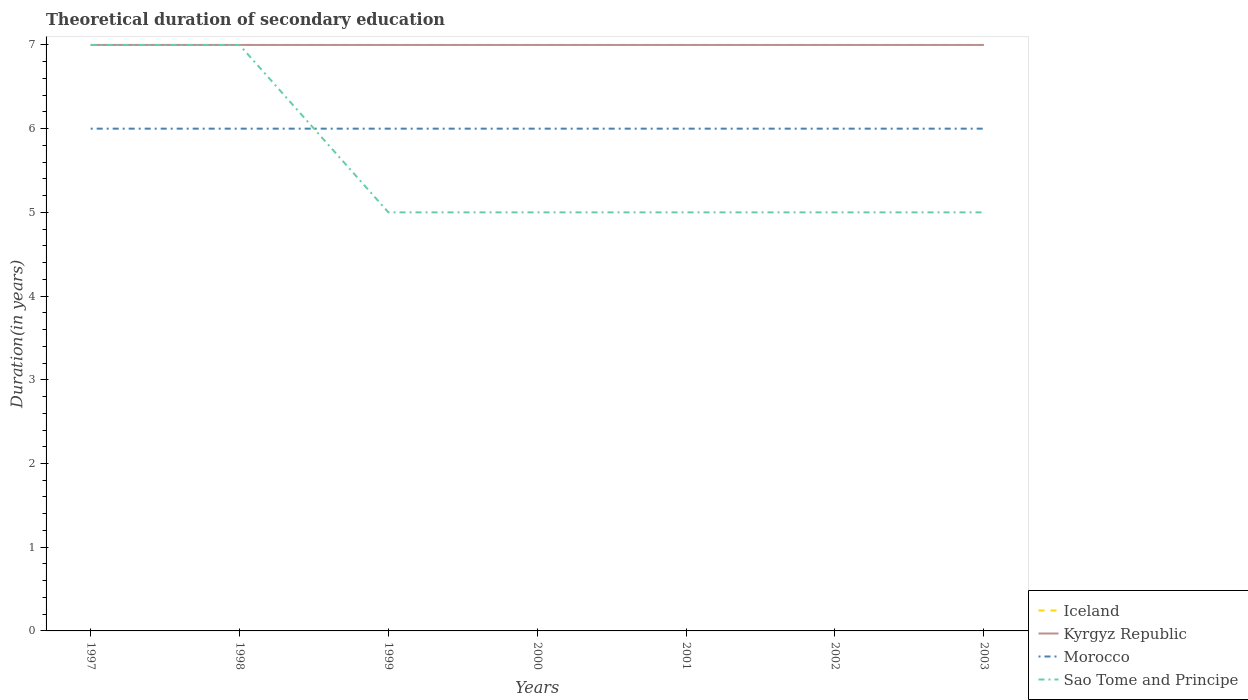Across all years, what is the maximum total theoretical duration of secondary education in Sao Tome and Principe?
Your answer should be compact. 5. What is the total total theoretical duration of secondary education in Sao Tome and Principe in the graph?
Offer a terse response. 2. What is the difference between the highest and the second highest total theoretical duration of secondary education in Sao Tome and Principe?
Your answer should be compact. 2. Is the total theoretical duration of secondary education in Sao Tome and Principe strictly greater than the total theoretical duration of secondary education in Kyrgyz Republic over the years?
Offer a very short reply. No. How many years are there in the graph?
Offer a terse response. 7. What is the difference between two consecutive major ticks on the Y-axis?
Your answer should be very brief. 1. Does the graph contain any zero values?
Your response must be concise. No. Does the graph contain grids?
Your answer should be compact. No. Where does the legend appear in the graph?
Provide a short and direct response. Bottom right. What is the title of the graph?
Your answer should be compact. Theoretical duration of secondary education. What is the label or title of the X-axis?
Keep it short and to the point. Years. What is the label or title of the Y-axis?
Provide a short and direct response. Duration(in years). What is the Duration(in years) in Morocco in 1997?
Provide a short and direct response. 6. What is the Duration(in years) of Sao Tome and Principe in 1997?
Your answer should be compact. 7. What is the Duration(in years) in Kyrgyz Republic in 1998?
Your answer should be compact. 7. What is the Duration(in years) in Iceland in 1999?
Give a very brief answer. 7. What is the Duration(in years) of Kyrgyz Republic in 1999?
Make the answer very short. 7. What is the Duration(in years) in Morocco in 1999?
Offer a very short reply. 6. What is the Duration(in years) of Kyrgyz Republic in 2000?
Your response must be concise. 7. What is the Duration(in years) of Morocco in 2000?
Make the answer very short. 6. What is the Duration(in years) of Morocco in 2001?
Keep it short and to the point. 6. What is the Duration(in years) of Sao Tome and Principe in 2001?
Give a very brief answer. 5. What is the Duration(in years) in Iceland in 2002?
Your answer should be compact. 7. What is the Duration(in years) of Kyrgyz Republic in 2002?
Keep it short and to the point. 7. What is the Duration(in years) of Morocco in 2002?
Give a very brief answer. 6. What is the Duration(in years) of Iceland in 2003?
Offer a very short reply. 7. What is the Duration(in years) in Kyrgyz Republic in 2003?
Your response must be concise. 7. What is the Duration(in years) of Morocco in 2003?
Your response must be concise. 6. Across all years, what is the maximum Duration(in years) of Kyrgyz Republic?
Make the answer very short. 7. Across all years, what is the maximum Duration(in years) in Morocco?
Your answer should be compact. 6. Across all years, what is the minimum Duration(in years) in Morocco?
Offer a terse response. 6. What is the total Duration(in years) in Kyrgyz Republic in the graph?
Give a very brief answer. 49. What is the total Duration(in years) in Morocco in the graph?
Your answer should be compact. 42. What is the total Duration(in years) in Sao Tome and Principe in the graph?
Give a very brief answer. 39. What is the difference between the Duration(in years) in Iceland in 1997 and that in 1999?
Keep it short and to the point. 0. What is the difference between the Duration(in years) of Kyrgyz Republic in 1997 and that in 1999?
Provide a succinct answer. 0. What is the difference between the Duration(in years) of Sao Tome and Principe in 1997 and that in 1999?
Provide a short and direct response. 2. What is the difference between the Duration(in years) in Iceland in 1997 and that in 2000?
Your answer should be compact. 0. What is the difference between the Duration(in years) of Sao Tome and Principe in 1997 and that in 2000?
Ensure brevity in your answer.  2. What is the difference between the Duration(in years) in Iceland in 1997 and that in 2001?
Your answer should be compact. 0. What is the difference between the Duration(in years) of Iceland in 1997 and that in 2002?
Give a very brief answer. 0. What is the difference between the Duration(in years) in Kyrgyz Republic in 1997 and that in 2002?
Keep it short and to the point. 0. What is the difference between the Duration(in years) in Morocco in 1997 and that in 2002?
Offer a terse response. 0. What is the difference between the Duration(in years) in Sao Tome and Principe in 1997 and that in 2002?
Your response must be concise. 2. What is the difference between the Duration(in years) of Iceland in 1997 and that in 2003?
Your response must be concise. 0. What is the difference between the Duration(in years) of Kyrgyz Republic in 1997 and that in 2003?
Keep it short and to the point. 0. What is the difference between the Duration(in years) of Iceland in 1998 and that in 1999?
Provide a short and direct response. 0. What is the difference between the Duration(in years) of Kyrgyz Republic in 1998 and that in 1999?
Make the answer very short. 0. What is the difference between the Duration(in years) in Kyrgyz Republic in 1998 and that in 2000?
Your response must be concise. 0. What is the difference between the Duration(in years) in Iceland in 1998 and that in 2001?
Your response must be concise. 0. What is the difference between the Duration(in years) of Iceland in 1998 and that in 2002?
Keep it short and to the point. 0. What is the difference between the Duration(in years) in Morocco in 1998 and that in 2002?
Offer a very short reply. 0. What is the difference between the Duration(in years) in Kyrgyz Republic in 1998 and that in 2003?
Offer a very short reply. 0. What is the difference between the Duration(in years) of Morocco in 1998 and that in 2003?
Give a very brief answer. 0. What is the difference between the Duration(in years) of Sao Tome and Principe in 1998 and that in 2003?
Offer a terse response. 2. What is the difference between the Duration(in years) in Iceland in 1999 and that in 2000?
Offer a terse response. 0. What is the difference between the Duration(in years) of Kyrgyz Republic in 1999 and that in 2000?
Give a very brief answer. 0. What is the difference between the Duration(in years) in Morocco in 1999 and that in 2000?
Make the answer very short. 0. What is the difference between the Duration(in years) in Iceland in 1999 and that in 2001?
Offer a very short reply. 0. What is the difference between the Duration(in years) in Sao Tome and Principe in 1999 and that in 2001?
Make the answer very short. 0. What is the difference between the Duration(in years) of Iceland in 1999 and that in 2002?
Your response must be concise. 0. What is the difference between the Duration(in years) in Morocco in 1999 and that in 2002?
Your response must be concise. 0. What is the difference between the Duration(in years) of Iceland in 1999 and that in 2003?
Provide a short and direct response. 0. What is the difference between the Duration(in years) in Morocco in 1999 and that in 2003?
Your answer should be very brief. 0. What is the difference between the Duration(in years) in Sao Tome and Principe in 2000 and that in 2001?
Offer a terse response. 0. What is the difference between the Duration(in years) of Iceland in 2000 and that in 2002?
Give a very brief answer. 0. What is the difference between the Duration(in years) in Kyrgyz Republic in 2000 and that in 2002?
Your answer should be compact. 0. What is the difference between the Duration(in years) of Iceland in 2000 and that in 2003?
Make the answer very short. 0. What is the difference between the Duration(in years) of Kyrgyz Republic in 2000 and that in 2003?
Offer a terse response. 0. What is the difference between the Duration(in years) in Morocco in 2000 and that in 2003?
Your response must be concise. 0. What is the difference between the Duration(in years) of Morocco in 2001 and that in 2002?
Give a very brief answer. 0. What is the difference between the Duration(in years) in Morocco in 2001 and that in 2003?
Your answer should be very brief. 0. What is the difference between the Duration(in years) in Iceland in 2002 and that in 2003?
Your answer should be compact. 0. What is the difference between the Duration(in years) in Kyrgyz Republic in 2002 and that in 2003?
Ensure brevity in your answer.  0. What is the difference between the Duration(in years) in Morocco in 2002 and that in 2003?
Ensure brevity in your answer.  0. What is the difference between the Duration(in years) in Sao Tome and Principe in 2002 and that in 2003?
Offer a terse response. 0. What is the difference between the Duration(in years) in Iceland in 1997 and the Duration(in years) in Sao Tome and Principe in 1998?
Give a very brief answer. 0. What is the difference between the Duration(in years) in Kyrgyz Republic in 1997 and the Duration(in years) in Sao Tome and Principe in 1998?
Provide a succinct answer. 0. What is the difference between the Duration(in years) of Iceland in 1997 and the Duration(in years) of Kyrgyz Republic in 1999?
Provide a succinct answer. 0. What is the difference between the Duration(in years) of Iceland in 1997 and the Duration(in years) of Sao Tome and Principe in 1999?
Give a very brief answer. 2. What is the difference between the Duration(in years) of Kyrgyz Republic in 1997 and the Duration(in years) of Sao Tome and Principe in 1999?
Give a very brief answer. 2. What is the difference between the Duration(in years) of Iceland in 1997 and the Duration(in years) of Kyrgyz Republic in 2000?
Offer a terse response. 0. What is the difference between the Duration(in years) in Iceland in 1997 and the Duration(in years) in Morocco in 2000?
Your response must be concise. 1. What is the difference between the Duration(in years) of Iceland in 1997 and the Duration(in years) of Sao Tome and Principe in 2000?
Provide a short and direct response. 2. What is the difference between the Duration(in years) of Kyrgyz Republic in 1997 and the Duration(in years) of Sao Tome and Principe in 2001?
Your answer should be compact. 2. What is the difference between the Duration(in years) of Iceland in 1997 and the Duration(in years) of Kyrgyz Republic in 2002?
Provide a short and direct response. 0. What is the difference between the Duration(in years) in Iceland in 1997 and the Duration(in years) in Morocco in 2002?
Your answer should be compact. 1. What is the difference between the Duration(in years) in Iceland in 1997 and the Duration(in years) in Sao Tome and Principe in 2002?
Your answer should be very brief. 2. What is the difference between the Duration(in years) in Kyrgyz Republic in 1997 and the Duration(in years) in Morocco in 2002?
Your response must be concise. 1. What is the difference between the Duration(in years) of Kyrgyz Republic in 1997 and the Duration(in years) of Sao Tome and Principe in 2002?
Ensure brevity in your answer.  2. What is the difference between the Duration(in years) in Morocco in 1997 and the Duration(in years) in Sao Tome and Principe in 2002?
Keep it short and to the point. 1. What is the difference between the Duration(in years) of Kyrgyz Republic in 1997 and the Duration(in years) of Morocco in 2003?
Make the answer very short. 1. What is the difference between the Duration(in years) of Morocco in 1997 and the Duration(in years) of Sao Tome and Principe in 2003?
Give a very brief answer. 1. What is the difference between the Duration(in years) of Iceland in 1998 and the Duration(in years) of Kyrgyz Republic in 1999?
Provide a succinct answer. 0. What is the difference between the Duration(in years) of Iceland in 1998 and the Duration(in years) of Morocco in 1999?
Your answer should be compact. 1. What is the difference between the Duration(in years) in Iceland in 1998 and the Duration(in years) in Sao Tome and Principe in 1999?
Make the answer very short. 2. What is the difference between the Duration(in years) in Iceland in 1998 and the Duration(in years) in Morocco in 2000?
Provide a succinct answer. 1. What is the difference between the Duration(in years) in Iceland in 1998 and the Duration(in years) in Sao Tome and Principe in 2000?
Your answer should be compact. 2. What is the difference between the Duration(in years) in Kyrgyz Republic in 1998 and the Duration(in years) in Morocco in 2000?
Your answer should be very brief. 1. What is the difference between the Duration(in years) in Morocco in 1998 and the Duration(in years) in Sao Tome and Principe in 2000?
Make the answer very short. 1. What is the difference between the Duration(in years) in Iceland in 1998 and the Duration(in years) in Kyrgyz Republic in 2001?
Ensure brevity in your answer.  0. What is the difference between the Duration(in years) of Iceland in 1998 and the Duration(in years) of Morocco in 2001?
Ensure brevity in your answer.  1. What is the difference between the Duration(in years) in Iceland in 1998 and the Duration(in years) in Sao Tome and Principe in 2001?
Offer a terse response. 2. What is the difference between the Duration(in years) of Kyrgyz Republic in 1998 and the Duration(in years) of Morocco in 2001?
Provide a succinct answer. 1. What is the difference between the Duration(in years) of Kyrgyz Republic in 1998 and the Duration(in years) of Sao Tome and Principe in 2001?
Provide a succinct answer. 2. What is the difference between the Duration(in years) of Iceland in 1998 and the Duration(in years) of Morocco in 2002?
Offer a terse response. 1. What is the difference between the Duration(in years) in Iceland in 1998 and the Duration(in years) in Sao Tome and Principe in 2002?
Ensure brevity in your answer.  2. What is the difference between the Duration(in years) in Kyrgyz Republic in 1998 and the Duration(in years) in Morocco in 2002?
Offer a very short reply. 1. What is the difference between the Duration(in years) in Kyrgyz Republic in 1998 and the Duration(in years) in Sao Tome and Principe in 2002?
Your answer should be compact. 2. What is the difference between the Duration(in years) of Morocco in 1998 and the Duration(in years) of Sao Tome and Principe in 2002?
Your answer should be compact. 1. What is the difference between the Duration(in years) in Iceland in 1998 and the Duration(in years) in Morocco in 2003?
Make the answer very short. 1. What is the difference between the Duration(in years) of Kyrgyz Republic in 1998 and the Duration(in years) of Morocco in 2003?
Give a very brief answer. 1. What is the difference between the Duration(in years) of Kyrgyz Republic in 1998 and the Duration(in years) of Sao Tome and Principe in 2003?
Offer a terse response. 2. What is the difference between the Duration(in years) in Morocco in 1998 and the Duration(in years) in Sao Tome and Principe in 2003?
Provide a short and direct response. 1. What is the difference between the Duration(in years) in Iceland in 1999 and the Duration(in years) in Sao Tome and Principe in 2000?
Ensure brevity in your answer.  2. What is the difference between the Duration(in years) in Kyrgyz Republic in 1999 and the Duration(in years) in Morocco in 2000?
Your response must be concise. 1. What is the difference between the Duration(in years) of Kyrgyz Republic in 1999 and the Duration(in years) of Sao Tome and Principe in 2000?
Offer a very short reply. 2. What is the difference between the Duration(in years) of Morocco in 1999 and the Duration(in years) of Sao Tome and Principe in 2001?
Make the answer very short. 1. What is the difference between the Duration(in years) of Iceland in 1999 and the Duration(in years) of Morocco in 2002?
Your answer should be compact. 1. What is the difference between the Duration(in years) of Kyrgyz Republic in 1999 and the Duration(in years) of Morocco in 2002?
Ensure brevity in your answer.  1. What is the difference between the Duration(in years) in Morocco in 1999 and the Duration(in years) in Sao Tome and Principe in 2002?
Offer a terse response. 1. What is the difference between the Duration(in years) in Iceland in 1999 and the Duration(in years) in Morocco in 2003?
Your answer should be compact. 1. What is the difference between the Duration(in years) of Iceland in 1999 and the Duration(in years) of Sao Tome and Principe in 2003?
Ensure brevity in your answer.  2. What is the difference between the Duration(in years) of Kyrgyz Republic in 1999 and the Duration(in years) of Sao Tome and Principe in 2003?
Keep it short and to the point. 2. What is the difference between the Duration(in years) of Morocco in 1999 and the Duration(in years) of Sao Tome and Principe in 2003?
Your answer should be very brief. 1. What is the difference between the Duration(in years) in Iceland in 2000 and the Duration(in years) in Kyrgyz Republic in 2001?
Ensure brevity in your answer.  0. What is the difference between the Duration(in years) in Kyrgyz Republic in 2000 and the Duration(in years) in Sao Tome and Principe in 2001?
Provide a succinct answer. 2. What is the difference between the Duration(in years) of Morocco in 2000 and the Duration(in years) of Sao Tome and Principe in 2001?
Your answer should be very brief. 1. What is the difference between the Duration(in years) in Iceland in 2000 and the Duration(in years) in Morocco in 2002?
Your answer should be very brief. 1. What is the difference between the Duration(in years) in Kyrgyz Republic in 2000 and the Duration(in years) in Morocco in 2002?
Your answer should be compact. 1. What is the difference between the Duration(in years) in Morocco in 2000 and the Duration(in years) in Sao Tome and Principe in 2002?
Ensure brevity in your answer.  1. What is the difference between the Duration(in years) in Iceland in 2000 and the Duration(in years) in Kyrgyz Republic in 2003?
Keep it short and to the point. 0. What is the difference between the Duration(in years) of Kyrgyz Republic in 2000 and the Duration(in years) of Morocco in 2003?
Offer a very short reply. 1. What is the difference between the Duration(in years) in Kyrgyz Republic in 2001 and the Duration(in years) in Morocco in 2002?
Your answer should be compact. 1. What is the difference between the Duration(in years) of Kyrgyz Republic in 2001 and the Duration(in years) of Sao Tome and Principe in 2002?
Your answer should be very brief. 2. What is the difference between the Duration(in years) in Iceland in 2001 and the Duration(in years) in Morocco in 2003?
Make the answer very short. 1. What is the difference between the Duration(in years) in Kyrgyz Republic in 2001 and the Duration(in years) in Sao Tome and Principe in 2003?
Provide a short and direct response. 2. What is the difference between the Duration(in years) in Iceland in 2002 and the Duration(in years) in Kyrgyz Republic in 2003?
Provide a succinct answer. 0. What is the difference between the Duration(in years) in Iceland in 2002 and the Duration(in years) in Morocco in 2003?
Keep it short and to the point. 1. What is the difference between the Duration(in years) of Iceland in 2002 and the Duration(in years) of Sao Tome and Principe in 2003?
Your answer should be compact. 2. What is the difference between the Duration(in years) in Kyrgyz Republic in 2002 and the Duration(in years) in Morocco in 2003?
Make the answer very short. 1. What is the difference between the Duration(in years) in Morocco in 2002 and the Duration(in years) in Sao Tome and Principe in 2003?
Your answer should be very brief. 1. What is the average Duration(in years) of Sao Tome and Principe per year?
Ensure brevity in your answer.  5.57. In the year 1998, what is the difference between the Duration(in years) in Iceland and Duration(in years) in Sao Tome and Principe?
Keep it short and to the point. 0. In the year 1998, what is the difference between the Duration(in years) of Kyrgyz Republic and Duration(in years) of Morocco?
Provide a succinct answer. 1. In the year 1998, what is the difference between the Duration(in years) of Kyrgyz Republic and Duration(in years) of Sao Tome and Principe?
Offer a very short reply. 0. In the year 1998, what is the difference between the Duration(in years) of Morocco and Duration(in years) of Sao Tome and Principe?
Your response must be concise. -1. In the year 1999, what is the difference between the Duration(in years) of Iceland and Duration(in years) of Kyrgyz Republic?
Your answer should be very brief. 0. In the year 1999, what is the difference between the Duration(in years) in Kyrgyz Republic and Duration(in years) in Sao Tome and Principe?
Your answer should be compact. 2. In the year 1999, what is the difference between the Duration(in years) of Morocco and Duration(in years) of Sao Tome and Principe?
Give a very brief answer. 1. In the year 2000, what is the difference between the Duration(in years) of Iceland and Duration(in years) of Kyrgyz Republic?
Keep it short and to the point. 0. In the year 2000, what is the difference between the Duration(in years) in Kyrgyz Republic and Duration(in years) in Morocco?
Provide a short and direct response. 1. In the year 2000, what is the difference between the Duration(in years) in Kyrgyz Republic and Duration(in years) in Sao Tome and Principe?
Offer a terse response. 2. In the year 2000, what is the difference between the Duration(in years) of Morocco and Duration(in years) of Sao Tome and Principe?
Ensure brevity in your answer.  1. In the year 2001, what is the difference between the Duration(in years) of Iceland and Duration(in years) of Sao Tome and Principe?
Keep it short and to the point. 2. In the year 2001, what is the difference between the Duration(in years) of Morocco and Duration(in years) of Sao Tome and Principe?
Your response must be concise. 1. In the year 2002, what is the difference between the Duration(in years) in Iceland and Duration(in years) in Sao Tome and Principe?
Offer a very short reply. 2. In the year 2002, what is the difference between the Duration(in years) of Kyrgyz Republic and Duration(in years) of Morocco?
Your response must be concise. 1. In the year 2002, what is the difference between the Duration(in years) of Kyrgyz Republic and Duration(in years) of Sao Tome and Principe?
Provide a short and direct response. 2. In the year 2002, what is the difference between the Duration(in years) of Morocco and Duration(in years) of Sao Tome and Principe?
Your answer should be very brief. 1. In the year 2003, what is the difference between the Duration(in years) in Iceland and Duration(in years) in Sao Tome and Principe?
Provide a succinct answer. 2. In the year 2003, what is the difference between the Duration(in years) of Morocco and Duration(in years) of Sao Tome and Principe?
Keep it short and to the point. 1. What is the ratio of the Duration(in years) in Iceland in 1997 to that in 1998?
Your response must be concise. 1. What is the ratio of the Duration(in years) of Kyrgyz Republic in 1997 to that in 1998?
Provide a short and direct response. 1. What is the ratio of the Duration(in years) in Sao Tome and Principe in 1997 to that in 1998?
Offer a terse response. 1. What is the ratio of the Duration(in years) in Kyrgyz Republic in 1997 to that in 1999?
Give a very brief answer. 1. What is the ratio of the Duration(in years) of Morocco in 1997 to that in 1999?
Offer a very short reply. 1. What is the ratio of the Duration(in years) of Morocco in 1997 to that in 2000?
Keep it short and to the point. 1. What is the ratio of the Duration(in years) in Iceland in 1997 to that in 2001?
Ensure brevity in your answer.  1. What is the ratio of the Duration(in years) in Morocco in 1997 to that in 2001?
Provide a succinct answer. 1. What is the ratio of the Duration(in years) in Iceland in 1997 to that in 2002?
Provide a short and direct response. 1. What is the ratio of the Duration(in years) in Sao Tome and Principe in 1997 to that in 2002?
Offer a very short reply. 1.4. What is the ratio of the Duration(in years) in Morocco in 1997 to that in 2003?
Your answer should be very brief. 1. What is the ratio of the Duration(in years) in Sao Tome and Principe in 1997 to that in 2003?
Provide a succinct answer. 1.4. What is the ratio of the Duration(in years) of Kyrgyz Republic in 1998 to that in 1999?
Offer a very short reply. 1. What is the ratio of the Duration(in years) of Iceland in 1998 to that in 2000?
Provide a short and direct response. 1. What is the ratio of the Duration(in years) in Sao Tome and Principe in 1998 to that in 2000?
Give a very brief answer. 1.4. What is the ratio of the Duration(in years) in Iceland in 1998 to that in 2001?
Provide a succinct answer. 1. What is the ratio of the Duration(in years) in Kyrgyz Republic in 1998 to that in 2001?
Offer a very short reply. 1. What is the ratio of the Duration(in years) in Morocco in 1998 to that in 2002?
Your answer should be compact. 1. What is the ratio of the Duration(in years) of Kyrgyz Republic in 1998 to that in 2003?
Make the answer very short. 1. What is the ratio of the Duration(in years) of Iceland in 1999 to that in 2000?
Provide a short and direct response. 1. What is the ratio of the Duration(in years) of Kyrgyz Republic in 1999 to that in 2001?
Provide a succinct answer. 1. What is the ratio of the Duration(in years) of Iceland in 1999 to that in 2002?
Ensure brevity in your answer.  1. What is the ratio of the Duration(in years) in Kyrgyz Republic in 1999 to that in 2002?
Offer a terse response. 1. What is the ratio of the Duration(in years) of Sao Tome and Principe in 1999 to that in 2002?
Make the answer very short. 1. What is the ratio of the Duration(in years) in Iceland in 1999 to that in 2003?
Give a very brief answer. 1. What is the ratio of the Duration(in years) of Kyrgyz Republic in 1999 to that in 2003?
Your response must be concise. 1. What is the ratio of the Duration(in years) in Sao Tome and Principe in 1999 to that in 2003?
Ensure brevity in your answer.  1. What is the ratio of the Duration(in years) in Kyrgyz Republic in 2000 to that in 2001?
Offer a terse response. 1. What is the ratio of the Duration(in years) in Sao Tome and Principe in 2000 to that in 2001?
Give a very brief answer. 1. What is the ratio of the Duration(in years) of Kyrgyz Republic in 2000 to that in 2002?
Give a very brief answer. 1. What is the ratio of the Duration(in years) in Morocco in 2000 to that in 2002?
Provide a succinct answer. 1. What is the ratio of the Duration(in years) in Iceland in 2000 to that in 2003?
Offer a very short reply. 1. What is the ratio of the Duration(in years) of Kyrgyz Republic in 2000 to that in 2003?
Provide a short and direct response. 1. What is the ratio of the Duration(in years) of Morocco in 2000 to that in 2003?
Provide a short and direct response. 1. What is the ratio of the Duration(in years) in Iceland in 2001 to that in 2002?
Ensure brevity in your answer.  1. What is the ratio of the Duration(in years) in Sao Tome and Principe in 2001 to that in 2002?
Make the answer very short. 1. What is the ratio of the Duration(in years) of Iceland in 2001 to that in 2003?
Provide a short and direct response. 1. What is the ratio of the Duration(in years) in Kyrgyz Republic in 2001 to that in 2003?
Your answer should be very brief. 1. What is the ratio of the Duration(in years) of Sao Tome and Principe in 2001 to that in 2003?
Make the answer very short. 1. What is the ratio of the Duration(in years) of Kyrgyz Republic in 2002 to that in 2003?
Your response must be concise. 1. What is the difference between the highest and the second highest Duration(in years) in Iceland?
Give a very brief answer. 0. What is the difference between the highest and the second highest Duration(in years) of Kyrgyz Republic?
Ensure brevity in your answer.  0. What is the difference between the highest and the second highest Duration(in years) of Morocco?
Offer a very short reply. 0. What is the difference between the highest and the second highest Duration(in years) in Sao Tome and Principe?
Your response must be concise. 0. What is the difference between the highest and the lowest Duration(in years) of Morocco?
Offer a very short reply. 0. What is the difference between the highest and the lowest Duration(in years) of Sao Tome and Principe?
Your answer should be very brief. 2. 